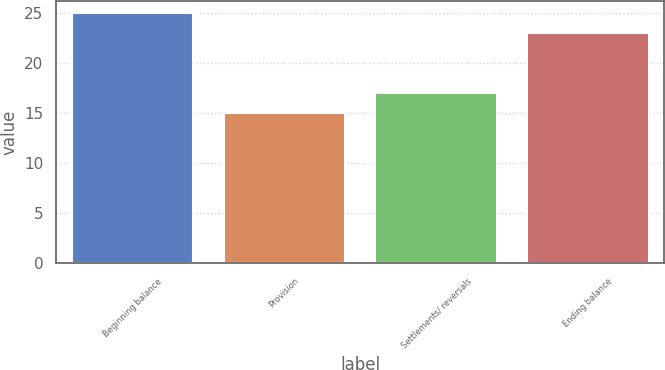Convert chart to OTSL. <chart><loc_0><loc_0><loc_500><loc_500><bar_chart><fcel>Beginning balance<fcel>Provision<fcel>Settlements/ reversals<fcel>Ending balance<nl><fcel>25<fcel>15<fcel>17<fcel>23<nl></chart> 